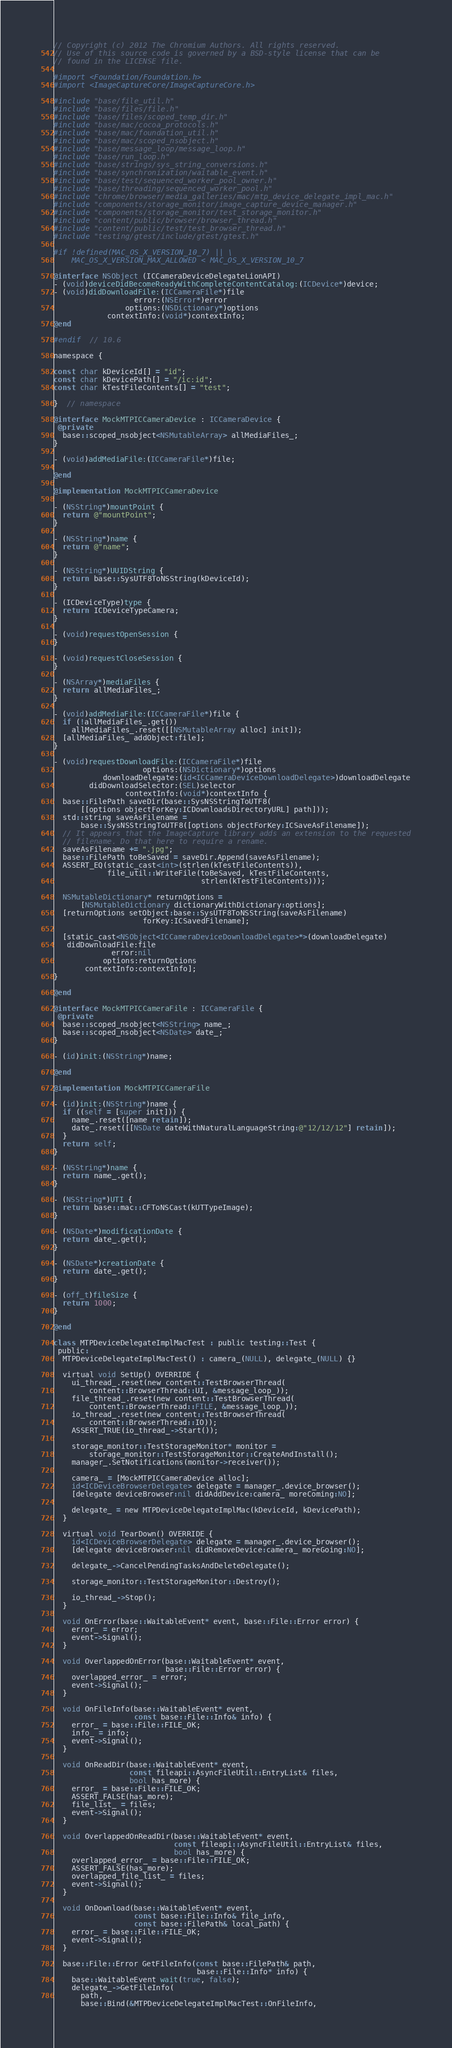<code> <loc_0><loc_0><loc_500><loc_500><_ObjectiveC_>// Copyright (c) 2012 The Chromium Authors. All rights reserved.
// Use of this source code is governed by a BSD-style license that can be
// found in the LICENSE file.

#import <Foundation/Foundation.h>
#import <ImageCaptureCore/ImageCaptureCore.h>

#include "base/file_util.h"
#include "base/files/file.h"
#include "base/files/scoped_temp_dir.h"
#include "base/mac/cocoa_protocols.h"
#include "base/mac/foundation_util.h"
#include "base/mac/scoped_nsobject.h"
#include "base/message_loop/message_loop.h"
#include "base/run_loop.h"
#include "base/strings/sys_string_conversions.h"
#include "base/synchronization/waitable_event.h"
#include "base/test/sequenced_worker_pool_owner.h"
#include "base/threading/sequenced_worker_pool.h"
#include "chrome/browser/media_galleries/mac/mtp_device_delegate_impl_mac.h"
#include "components/storage_monitor/image_capture_device_manager.h"
#include "components/storage_monitor/test_storage_monitor.h"
#include "content/public/browser/browser_thread.h"
#include "content/public/test/test_browser_thread.h"
#include "testing/gtest/include/gtest/gtest.h"

#if !defined(MAC_OS_X_VERSION_10_7) || \
    MAC_OS_X_VERSION_MAX_ALLOWED < MAC_OS_X_VERSION_10_7

@interface NSObject (ICCameraDeviceDelegateLionAPI)
- (void)deviceDidBecomeReadyWithCompleteContentCatalog:(ICDevice*)device;
- (void)didDownloadFile:(ICCameraFile*)file
                  error:(NSError*)error
                options:(NSDictionary*)options
            contextInfo:(void*)contextInfo;
@end

#endif  // 10.6

namespace {

const char kDeviceId[] = "id";
const char kDevicePath[] = "/ic:id";
const char kTestFileContents[] = "test";

}  // namespace

@interface MockMTPICCameraDevice : ICCameraDevice {
 @private
  base::scoped_nsobject<NSMutableArray> allMediaFiles_;
}

- (void)addMediaFile:(ICCameraFile*)file;

@end

@implementation MockMTPICCameraDevice

- (NSString*)mountPoint {
  return @"mountPoint";
}

- (NSString*)name {
  return @"name";
}

- (NSString*)UUIDString {
  return base::SysUTF8ToNSString(kDeviceId);
}

- (ICDeviceType)type {
  return ICDeviceTypeCamera;
}

- (void)requestOpenSession {
}

- (void)requestCloseSession {
}

- (NSArray*)mediaFiles {
  return allMediaFiles_;
}

- (void)addMediaFile:(ICCameraFile*)file {
  if (!allMediaFiles_.get())
    allMediaFiles_.reset([[NSMutableArray alloc] init]);
  [allMediaFiles_ addObject:file];
}

- (void)requestDownloadFile:(ICCameraFile*)file
                    options:(NSDictionary*)options
           downloadDelegate:(id<ICCameraDeviceDownloadDelegate>)downloadDelegate
        didDownloadSelector:(SEL)selector
                contextInfo:(void*)contextInfo {
  base::FilePath saveDir(base::SysNSStringToUTF8(
      [[options objectForKey:ICDownloadsDirectoryURL] path]));
  std::string saveAsFilename =
      base::SysNSStringToUTF8([options objectForKey:ICSaveAsFilename]);
  // It appears that the ImageCapture library adds an extension to the requested
  // filename. Do that here to require a rename.
  saveAsFilename += ".jpg";
  base::FilePath toBeSaved = saveDir.Append(saveAsFilename);
  ASSERT_EQ(static_cast<int>(strlen(kTestFileContents)),
            file_util::WriteFile(toBeSaved, kTestFileContents,
                                 strlen(kTestFileContents)));

  NSMutableDictionary* returnOptions =
      [NSMutableDictionary dictionaryWithDictionary:options];
  [returnOptions setObject:base::SysUTF8ToNSString(saveAsFilename)
                    forKey:ICSavedFilename];

  [static_cast<NSObject<ICCameraDeviceDownloadDelegate>*>(downloadDelegate)
   didDownloadFile:file
             error:nil
           options:returnOptions
       contextInfo:contextInfo];
}

@end

@interface MockMTPICCameraFile : ICCameraFile {
 @private
  base::scoped_nsobject<NSString> name_;
  base::scoped_nsobject<NSDate> date_;
}

- (id)init:(NSString*)name;

@end

@implementation MockMTPICCameraFile

- (id)init:(NSString*)name {
  if ((self = [super init])) {
    name_.reset([name retain]);
    date_.reset([[NSDate dateWithNaturalLanguageString:@"12/12/12"] retain]);
  }
  return self;
}

- (NSString*)name {
  return name_.get();
}

- (NSString*)UTI {
  return base::mac::CFToNSCast(kUTTypeImage);
}

- (NSDate*)modificationDate {
  return date_.get();
}

- (NSDate*)creationDate {
  return date_.get();
}

- (off_t)fileSize {
  return 1000;
}

@end

class MTPDeviceDelegateImplMacTest : public testing::Test {
 public:
  MTPDeviceDelegateImplMacTest() : camera_(NULL), delegate_(NULL) {}

  virtual void SetUp() OVERRIDE {
    ui_thread_.reset(new content::TestBrowserThread(
        content::BrowserThread::UI, &message_loop_));
    file_thread_.reset(new content::TestBrowserThread(
        content::BrowserThread::FILE, &message_loop_));
    io_thread_.reset(new content::TestBrowserThread(
        content::BrowserThread::IO));
    ASSERT_TRUE(io_thread_->Start());

    storage_monitor::TestStorageMonitor* monitor =
        storage_monitor::TestStorageMonitor::CreateAndInstall();
    manager_.SetNotifications(monitor->receiver());

    camera_ = [MockMTPICCameraDevice alloc];
    id<ICDeviceBrowserDelegate> delegate = manager_.device_browser();
    [delegate deviceBrowser:nil didAddDevice:camera_ moreComing:NO];

    delegate_ = new MTPDeviceDelegateImplMac(kDeviceId, kDevicePath);
  }

  virtual void TearDown() OVERRIDE {
    id<ICDeviceBrowserDelegate> delegate = manager_.device_browser();
    [delegate deviceBrowser:nil didRemoveDevice:camera_ moreGoing:NO];

    delegate_->CancelPendingTasksAndDeleteDelegate();

    storage_monitor::TestStorageMonitor::Destroy();

    io_thread_->Stop();
  }

  void OnError(base::WaitableEvent* event, base::File::Error error) {
    error_ = error;
    event->Signal();
  }

  void OverlappedOnError(base::WaitableEvent* event,
                         base::File::Error error) {
    overlapped_error_ = error;
    event->Signal();
  }

  void OnFileInfo(base::WaitableEvent* event,
                  const base::File::Info& info) {
    error_ = base::File::FILE_OK;
    info_ = info;
    event->Signal();
  }

  void OnReadDir(base::WaitableEvent* event,
                 const fileapi::AsyncFileUtil::EntryList& files,
                 bool has_more) {
    error_ = base::File::FILE_OK;
    ASSERT_FALSE(has_more);
    file_list_ = files;
    event->Signal();
  }

  void OverlappedOnReadDir(base::WaitableEvent* event,
                           const fileapi::AsyncFileUtil::EntryList& files,
                           bool has_more) {
    overlapped_error_ = base::File::FILE_OK;
    ASSERT_FALSE(has_more);
    overlapped_file_list_ = files;
    event->Signal();
  }

  void OnDownload(base::WaitableEvent* event,
                  const base::File::Info& file_info,
                  const base::FilePath& local_path) {
    error_ = base::File::FILE_OK;
    event->Signal();
  }

  base::File::Error GetFileInfo(const base::FilePath& path,
                                base::File::Info* info) {
    base::WaitableEvent wait(true, false);
    delegate_->GetFileInfo(
      path,
      base::Bind(&MTPDeviceDelegateImplMacTest::OnFileInfo,</code> 